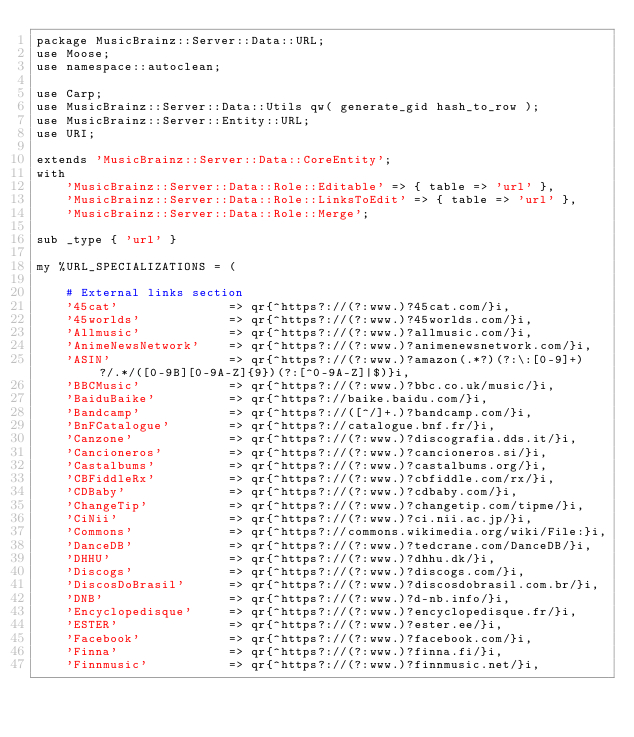Convert code to text. <code><loc_0><loc_0><loc_500><loc_500><_Perl_>package MusicBrainz::Server::Data::URL;
use Moose;
use namespace::autoclean;

use Carp;
use MusicBrainz::Server::Data::Utils qw( generate_gid hash_to_row );
use MusicBrainz::Server::Entity::URL;
use URI;

extends 'MusicBrainz::Server::Data::CoreEntity';
with
    'MusicBrainz::Server::Data::Role::Editable' => { table => 'url' },
    'MusicBrainz::Server::Data::Role::LinksToEdit' => { table => 'url' },
    'MusicBrainz::Server::Data::Role::Merge';

sub _type { 'url' }

my %URL_SPECIALIZATIONS = (

    # External links section
    '45cat'               => qr{^https?://(?:www.)?45cat.com/}i,
    '45worlds'            => qr{^https?://(?:www.)?45worlds.com/}i,
    'Allmusic'            => qr{^https?://(?:www.)?allmusic.com/}i,
    'AnimeNewsNetwork'    => qr{^https?://(?:www.)?animenewsnetwork.com/}i,
    'ASIN'                => qr{^https?://(?:www.)?amazon(.*?)(?:\:[0-9]+)?/.*/([0-9B][0-9A-Z]{9})(?:[^0-9A-Z]|$)}i,
    'BBCMusic'            => qr{^https?://(?:www.)?bbc.co.uk/music/}i,
    'BaiduBaike'          => qr{^https?://baike.baidu.com/}i,
    'Bandcamp'            => qr{^https?://([^/]+.)?bandcamp.com/}i,
    'BnFCatalogue'        => qr{^https?://catalogue.bnf.fr/}i,
    'Canzone'             => qr{^https?://(?:www.)?discografia.dds.it/}i,
    'Cancioneros'         => qr{^https?://(?:www.)?cancioneros.si/}i,
    'Castalbums'          => qr{^https?://(?:www.)?castalbums.org/}i,
    'CBFiddleRx'          => qr{^https?://(?:www.)?cbfiddle.com/rx/}i,
    'CDBaby'              => qr{^https?://(?:www.)?cdbaby.com/}i,
    'ChangeTip'           => qr{^https?://(?:www.)?changetip.com/tipme/}i,
    'CiNii'               => qr{^https?://(?:www.)?ci.nii.ac.jp/}i,
    'Commons'             => qr{^https?://commons.wikimedia.org/wiki/File:}i,
    'DanceDB'             => qr{^https?://(?:www.)?tedcrane.com/DanceDB/}i,
    'DHHU'                => qr{^https?://(?:www.)?dhhu.dk/}i,
    'Discogs'             => qr{^https?://(?:www.)?discogs.com/}i,
    'DiscosDoBrasil'      => qr{^https?://(?:www.)?discosdobrasil.com.br/}i,
    'DNB'                 => qr{^https?://(?:www.)?d-nb.info/}i,
    'Encyclopedisque'     => qr{^https?://(?:www.)?encyclopedisque.fr/}i,
    'ESTER'               => qr{^https?://(?:www.)?ester.ee/}i,
    'Facebook'            => qr{^https?://(?:www.)?facebook.com/}i,
    'Finna'               => qr{^https?://(?:www.)?finna.fi/}i,
    'Finnmusic'           => qr{^https?://(?:www.)?finnmusic.net/}i,</code> 